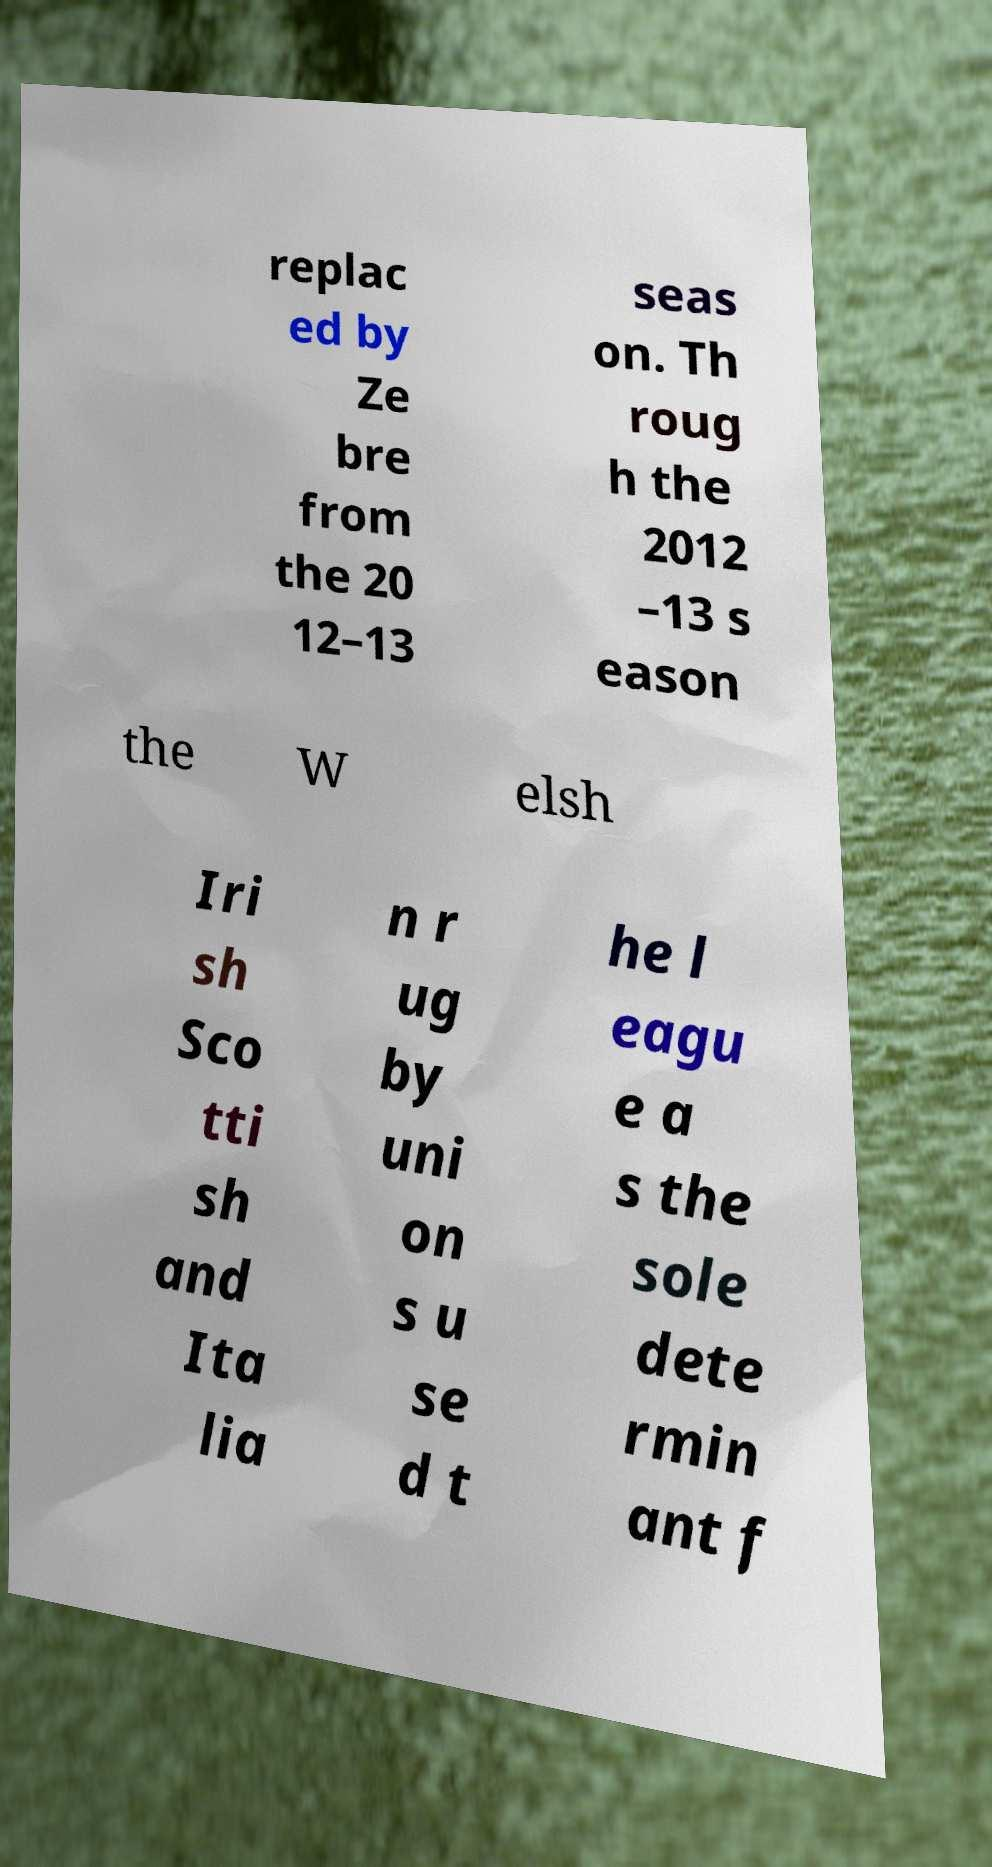There's text embedded in this image that I need extracted. Can you transcribe it verbatim? replac ed by Ze bre from the 20 12–13 seas on. Th roug h the 2012 –13 s eason the W elsh Iri sh Sco tti sh and Ita lia n r ug by uni on s u se d t he l eagu e a s the sole dete rmin ant f 